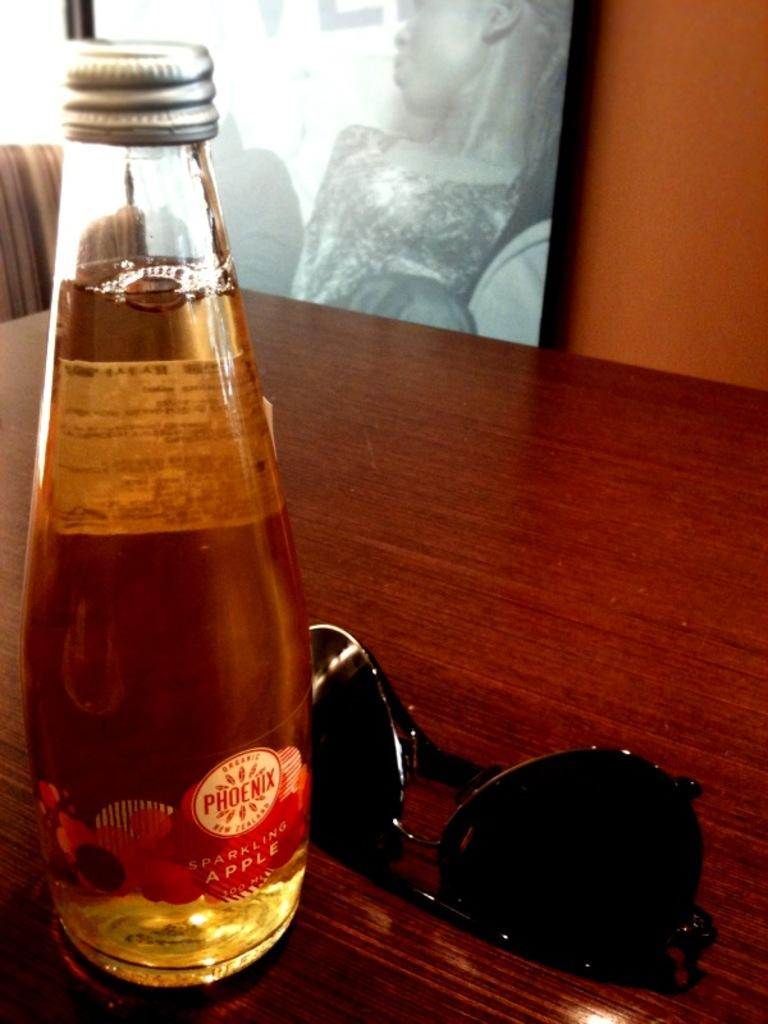<image>
Give a short and clear explanation of the subsequent image. A pair of sunglasses beside a bottle of Phoenix from New Zealand. 